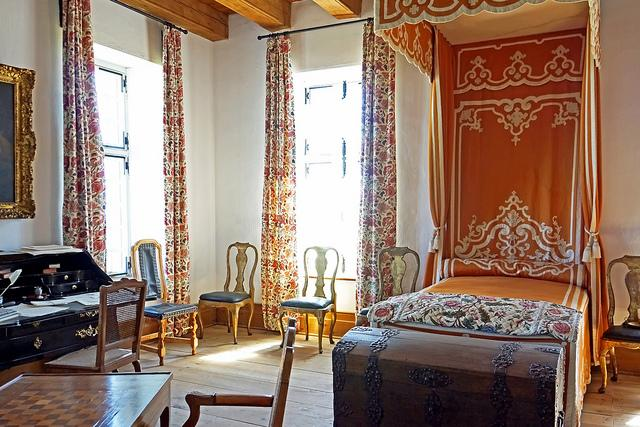What is the brown table at the left bottom corner for? chess 